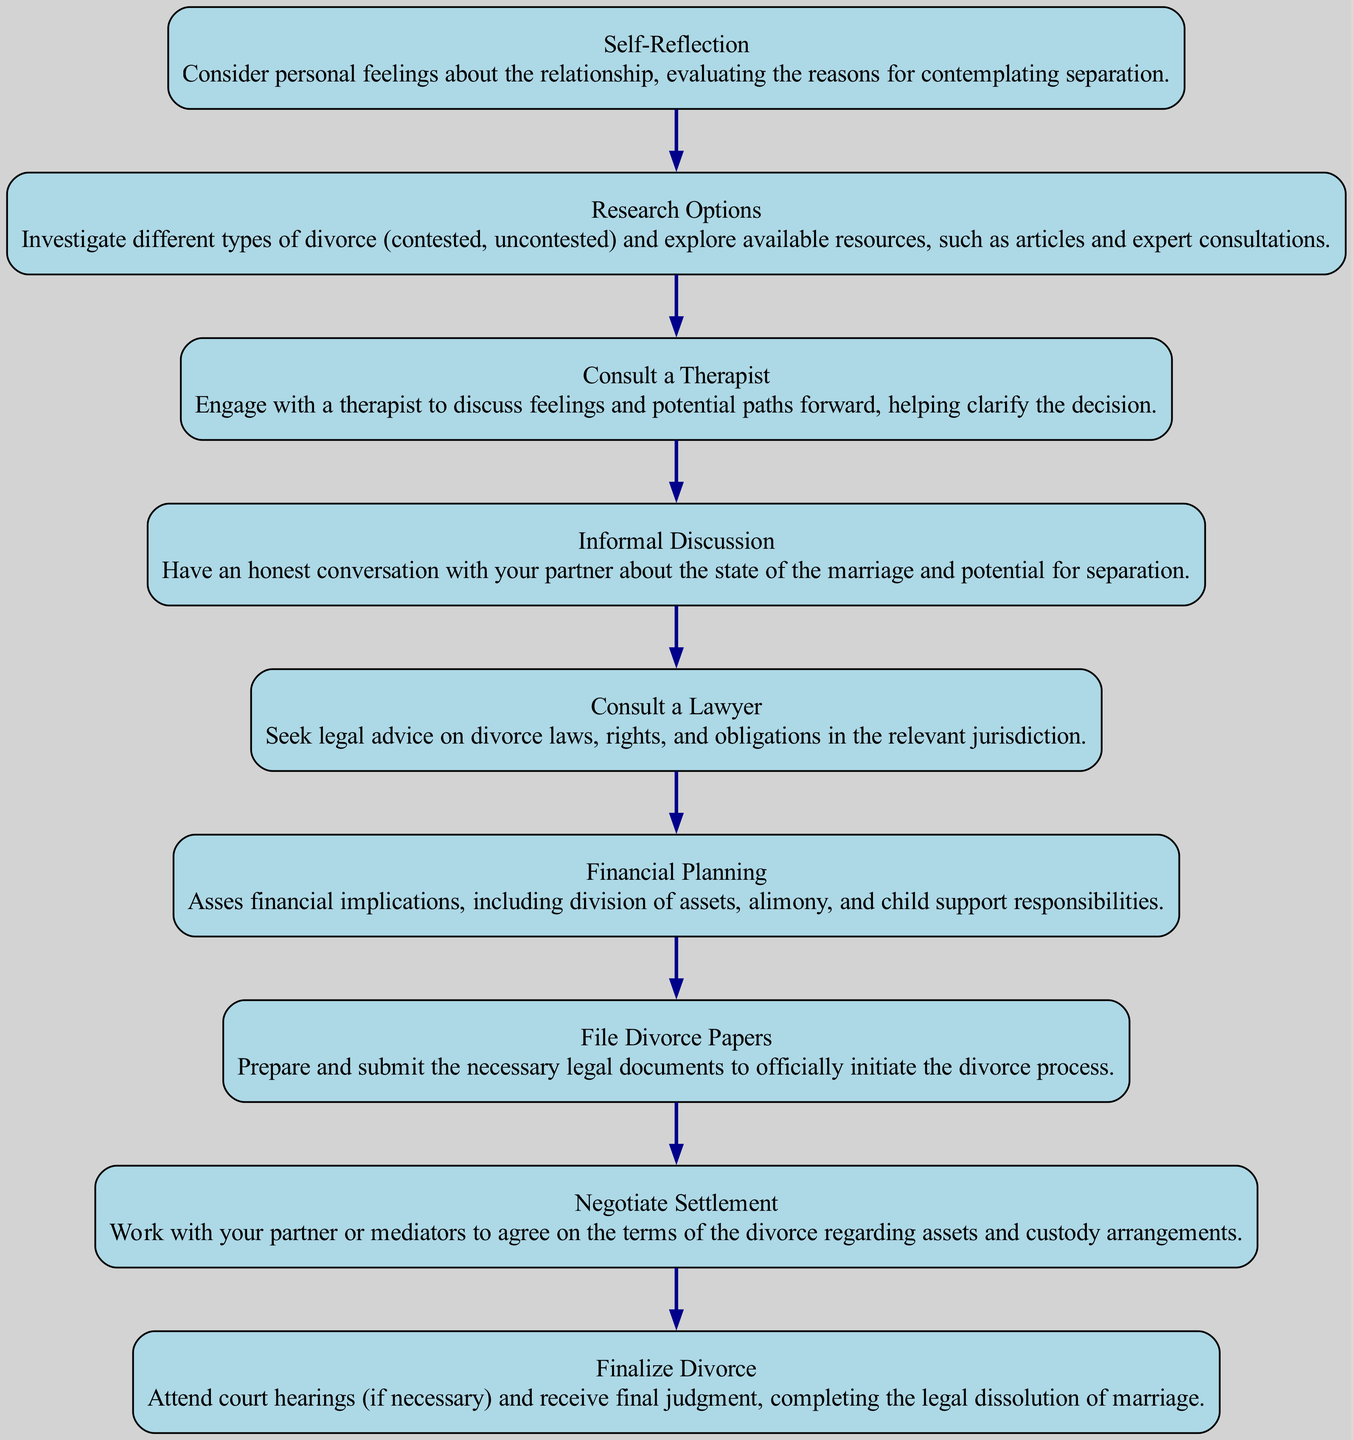What is the first step in the divorce process? The diagram indicates that the first step is "Self-Reflection." This is the initial node that begins the sequential flow of actions in the divorce process.
Answer: Self-Reflection How many total steps are there in the diagram? By counting the individual nodes listed, there are a total of nine distinct steps shown in the diagram, from "Self-Reflection" to "Finalize Divorce."
Answer: 9 What is the last step before filing legal documents? The final step before filing the divorce papers is "Consult a Lawyer," which outlines the need to seek legal advice on rights and obligations.
Answer: Consult a Lawyer What step involves financial implications? The process includes a step labeled "Financial Planning," which specifically addresses assessing financial implications related to the divorce.
Answer: Financial Planning What relationship is illustrated between "Negotiate Settlement" and "Finalize Divorce"? In the diagram, "Negotiate Settlement" comes directly before "Finalize Divorce," indicating a necessary step in the process where parties must reach an agreement before completing the divorce.
Answer: Direct relation What is the step that requires engagement with a therapist? The diagram shows "Consult a Therapist" as the third step, which emphasizes the importance of discussing feelings and potential paths forward in the divorce journey.
Answer: Consult a Therapist Which step focuses on options for divorce types? The diagram indicates "Research Options" as the second step, where individuals investigate different types of divorce, including whether it will be contested or uncontested.
Answer: Research Options How many steps are required before reaching a court hearing? According to the diagram, two key steps must occur before potentially attending court for a divorce: "Negotiate Settlement" and then "Finalize Divorce." This indicates those two are prerequisites for court hearings.
Answer: 2 What action should be taken after engaging in an informal discussion? Following an "Informal Discussion," the next step is to "Consult a Lawyer," suggesting that further legal advice is needed after assessing the state of the marriage.
Answer: Consult a Lawyer 